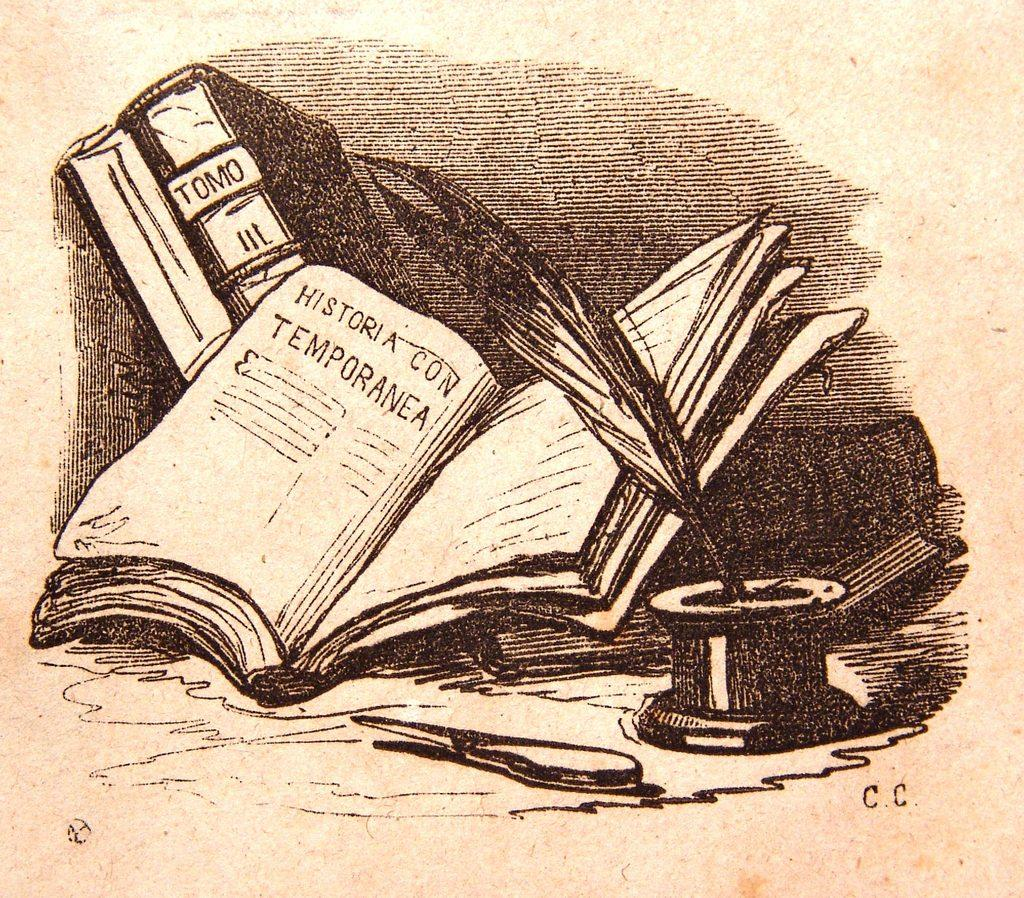<image>
Render a clear and concise summary of the photo. A handmade illustration of a quill in ink in front of an open book on a page titled "HISTORIA CONTEMPORANEA". 